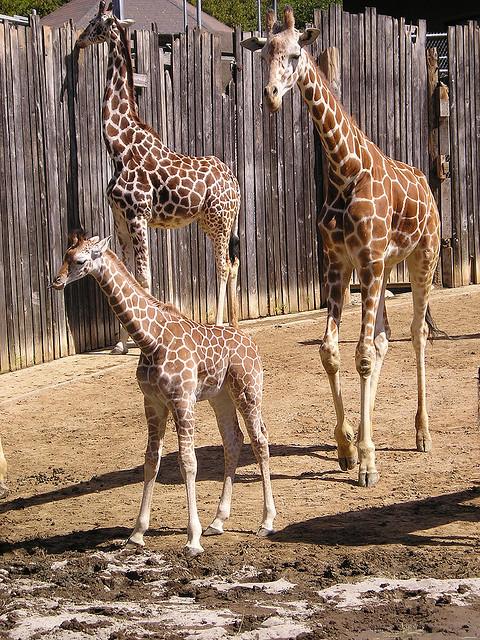What is covering the ground?
Keep it brief. Dirt. How many spots extend down the left side of the smallest giraffe's neck?
Give a very brief answer. 7. How many adult giraffes?
Concise answer only. 2. 